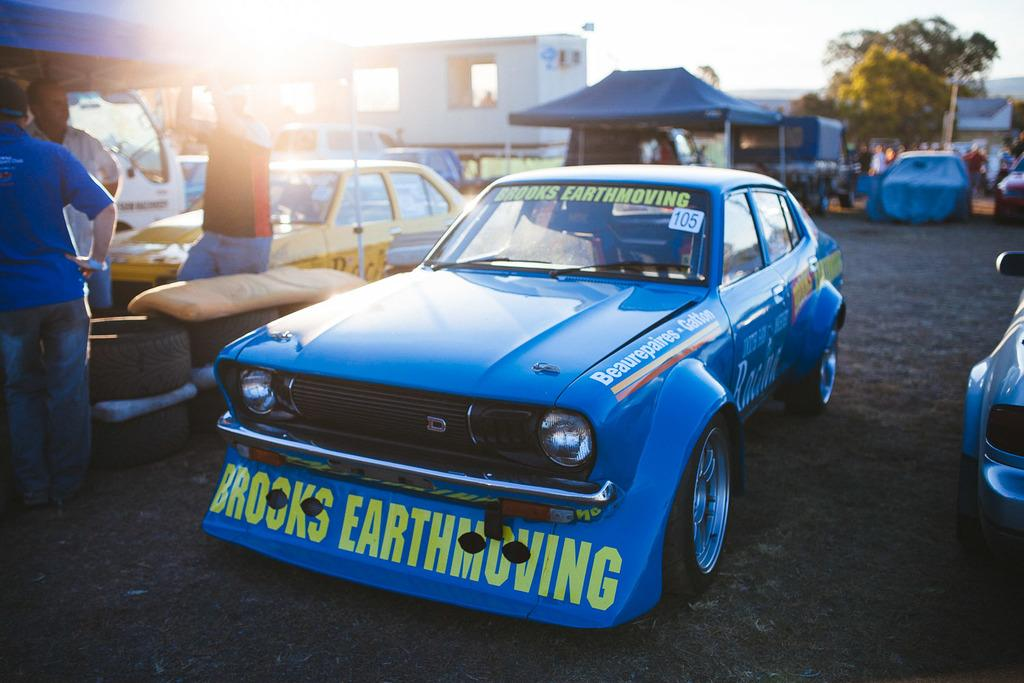What can be seen on the road in the image? There are vehicles on the road in the image. What else is present in the image besides the vehicles? There is a group of people, tyres, canopy tents, trees, and the sky is visible in the background of the image. How many bananas are hanging from the trees in the image? There are no bananas present in the image; only trees are visible. What type of balls can be seen being used by the group of people in the image? There are no balls present in the image; the group of people is not engaged in any ball-related activities. 